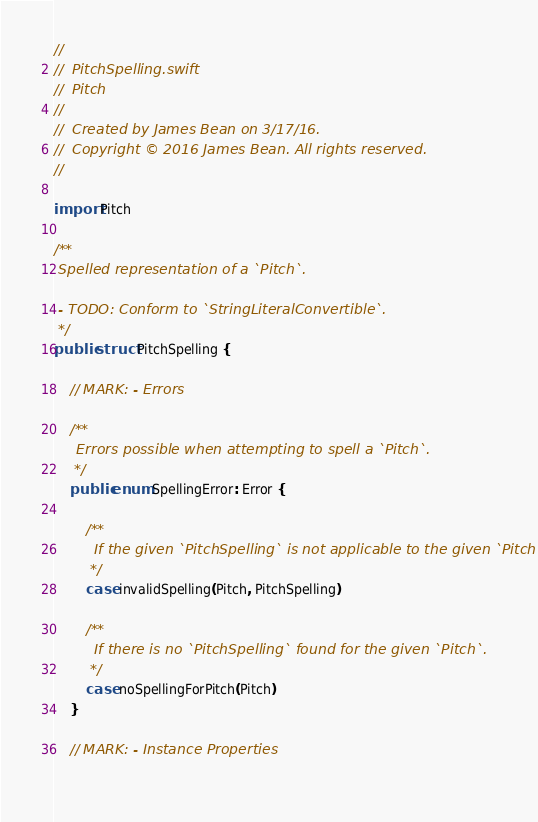Convert code to text. <code><loc_0><loc_0><loc_500><loc_500><_Swift_>//
//  PitchSpelling.swift
//  Pitch
//
//  Created by James Bean on 3/17/16.
//  Copyright © 2016 James Bean. All rights reserved.
//

import Pitch

/**
 Spelled representation of a `Pitch`.
 
 - TODO: Conform to `StringLiteralConvertible`.
 */
public struct PitchSpelling {
    
    // MARK: - Errors
    
    /**
     Errors possible when attempting to spell a `Pitch`.
     */
    public enum SpellingError: Error {
        
        /**
         If the given `PitchSpelling` is not applicable to the given `Pitch`.
         */
        case invalidSpelling(Pitch, PitchSpelling)
        
        /**
         If there is no `PitchSpelling` found for the given `Pitch`.
         */
        case noSpellingForPitch(Pitch)
    }
    
    // MARK: - Instance Properties
    </code> 